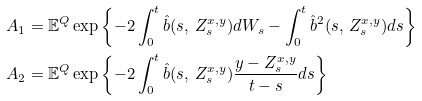Convert formula to latex. <formula><loc_0><loc_0><loc_500><loc_500>A _ { 1 } & = \mathbb { E } ^ { Q } \exp \left \{ - 2 \int _ { 0 } ^ { t } \hat { b } ( s , \, Z _ { s } ^ { x , y } ) d W _ { s } - \int _ { 0 } ^ { t } \hat { b } ^ { 2 } ( s , \, Z _ { s } ^ { x , y } ) d s \right \} \\ A _ { 2 } & = \mathbb { E } ^ { Q } \exp \left \{ - 2 \int _ { 0 } ^ { t } \hat { b } ( s , \, Z _ { s } ^ { x , y } ) \frac { y - Z _ { s } ^ { x , y } } { t - s } d s \right \}</formula> 